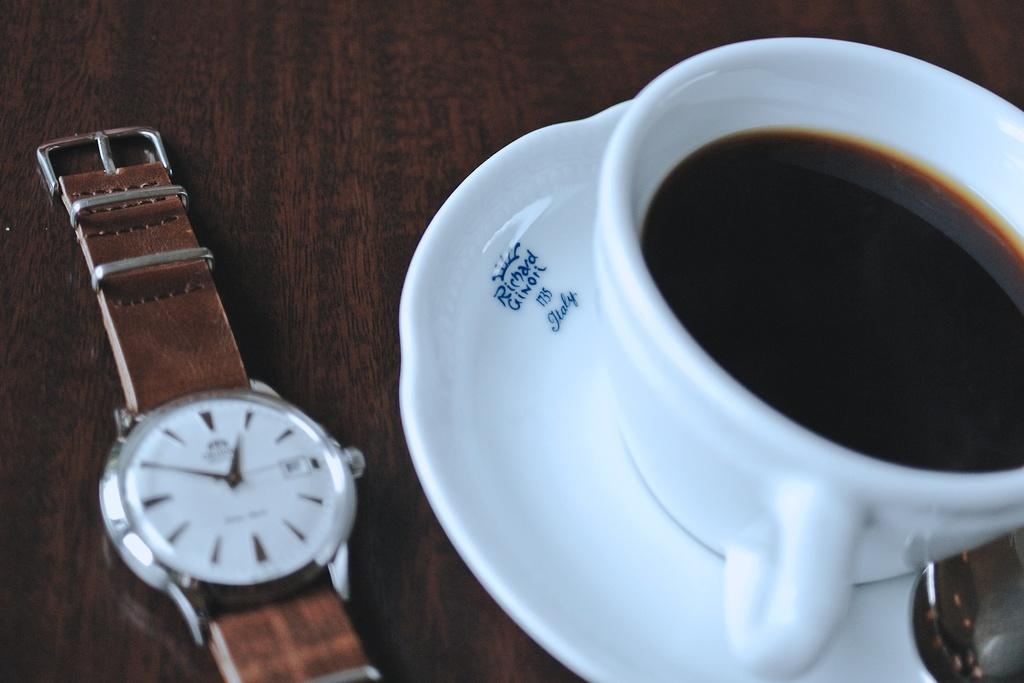<image>
Offer a succinct explanation of the picture presented. White cup on top of a white plate that says ITALY on it. 